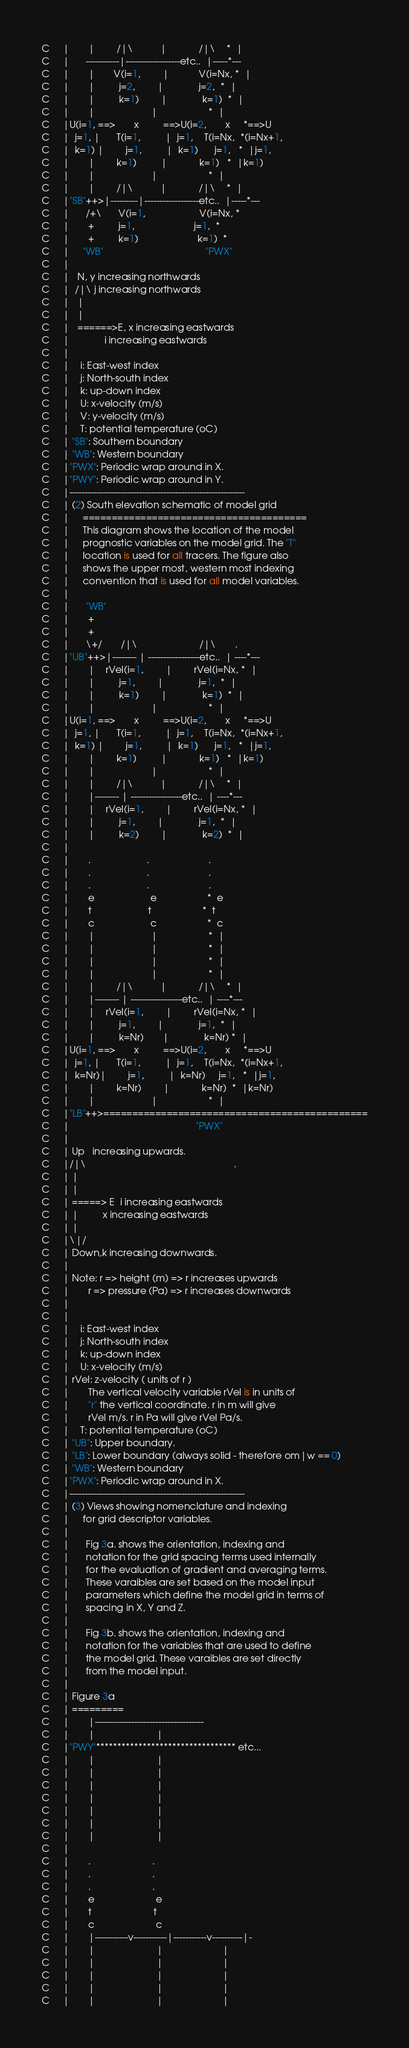Convert code to text. <code><loc_0><loc_0><loc_500><loc_500><_FORTRAN_>C     |       |        /|\          |            /|\    *  |
C     |      -----------|------------------etc..  |-----*---
C     |       |       V(i=1,        |           V(i=Nx, *  |
C     |       |         j=2,        |             j=2,  *  |
C     |       |         k=1)        |             k=1)  *  |
C     |       |                     |                   *  |
C     |U(i=1, ==>       x         ==>U(i=2,       x     *==>U
C     |  j=1, |      T(i=1,         |  j=1,    T(i=Nx,  *(i=Nx+1,
C     |  k=1) |        j=1,         |  k=1)      j=1,   *  |j=1,
C     |       |        k=1)         |            k=1)   *  |k=1)
C     |       |                     |                   *  |
C     |       |        /|\          |            /|\    *  |
C     |"SB"++>|---------|------------------etc..  |-----*---
C     |      /+\      V(i=1,                    V(i=Nx, *
C     |       +         j=1,                      j=1,  *
C     |       +         k=1)                      k=1)  *
C     |     "WB"                                      "PWX"
C     |
C     |   N, y increasing northwards
C     |  /|\ j increasing northwards
C     |   |
C     |   |
C     |   ======>E, x increasing eastwards
C     |             i increasing eastwards
C     |
C     |    i: East-west index
C     |    j: North-south index
C     |    k: up-down index
C     |    U: x-velocity (m/s)
C     |    V: y-velocity (m/s)
C     |    T: potential temperature (oC)
C     | "SB": Southern boundary
C     | "WB": Western boundary
C     |"PWX": Periodic wrap around in X.
C     |"PWY": Periodic wrap around in Y.
C     |----------------------------------------------------------
C     | (2) South elevation schematic of model grid
C     |     =======================================
C     |     This diagram shows the location of the model
C     |     prognostic variables on the model grid. The "T"
C     |     location is used for all tracers. The figure also
C     |     shows the upper most, western most indexing
C     |     convention that is used for all model variables.
C     |
C     |      "WB"
C     |       +
C     |       +
C     |      \+/       /|\                       /|\       .
C     |"UB"++>|-------- | -----------------etc..  | ----*---
C     |       |    rVel(i=1,        |        rVel(i=Nx, *  |
C     |       |         j=1,        |             j=1,  *  |
C     |       |         k=1)        |             k=1)  *  |
C     |       |                     |                   *  |
C     |U(i=1, ==>       x         ==>U(i=2,       x     *==>U
C     |  j=1, |      T(i=1,         |  j=1,    T(i=Nx,  *(i=Nx+1,
C     |  k=1) |        j=1,         |  k=1)      j=1,   *  |j=1,
C     |       |        k=1)         |            k=1)   *  |k=1)
C     |       |                     |                   *  |
C     |       |        /|\          |            /|\    *  |
C     |       |-------- | -----------------etc..  | ----*---
C     |       |    rVel(i=1,        |        rVel(i=Nx, *  |
C     |       |         j=1,        |             j=1,  *  |
C     |       |         k=2)        |             k=2)  *  |
C     |
C     |       .                     .                      .
C     |       .                     .                      .
C     |       .                     .                      .
C     |       e                     e                   *  e
C     |       t                     t                   *  t
C     |       c                     c                   *  c
C     |       |                     |                   *  |
C     |       |                     |                   *  |
C     |       |                     |                   *  |
C     |       |                     |                   *  |
C     |       |        /|\          |            /|\    *  |
C     |       |-------- | -----------------etc..  | ----*---
C     |       |    rVel(i=1,        |        rVel(i=Nx, *  |
C     |       |         j=1,        |             j=1,  *  |
C     |       |         k=Nr)       |             k=Nr) *  |
C     |U(i=1, ==>       x         ==>U(i=2,       x     *==>U
C     |  j=1, |      T(i=1,         |  j=1,    T(i=Nx,  *(i=Nx+1,
C     |  k=Nr)|        j=1,         |  k=Nr)     j=1,   *  |j=1,
C     |       |        k=Nr)        |            k=Nr)  *  |k=Nr)
C     |       |                     |                   *  |
C     |"LB"++>==============================================
C     |                                               "PWX"
C     |
C     | Up   increasing upwards.
C     |/|\                                                       .
C     | |
C     | |
C     | =====> E  i increasing eastwards
C     | |         x increasing eastwards
C     | |
C     |\|/
C     | Down,k increasing downwards.
C     |
C     | Note: r => height (m) => r increases upwards
C     |       r => pressure (Pa) => r increases downwards
C     |
C     |
C     |    i: East-west index
C     |    j: North-south index
C     |    k: up-down index
C     |    U: x-velocity (m/s)
C     | rVel: z-velocity ( units of r )
C     |       The vertical velocity variable rVel is in units of
C     |       "r" the vertical coordinate. r in m will give
C     |       rVel m/s. r in Pa will give rVel Pa/s.
C     |    T: potential temperature (oC)
C     | "UB": Upper boundary.
C     | "LB": Lower boundary (always solid - therefore om|w == 0)
C     | "WB": Western boundary
C     |"PWX": Periodic wrap around in X.
C     |----------------------------------------------------------
C     | (3) Views showing nomenclature and indexing
C     |     for grid descriptor variables.
C     |
C     |      Fig 3a. shows the orientation, indexing and
C     |      notation for the grid spacing terms used internally
C     |      for the evaluation of gradient and averaging terms.
C     |      These varaibles are set based on the model input
C     |      parameters which define the model grid in terms of
C     |      spacing in X, Y and Z.
C     |
C     |      Fig 3b. shows the orientation, indexing and
C     |      notation for the variables that are used to define
C     |      the model grid. These varaibles are set directly
C     |      from the model input.
C     |
C     | Figure 3a
C     | =========
C     |       |------------------------------------
C     |       |                       |
C     |"PWY"********************************* etc...
C     |       |                       |
C     |       |                       |
C     |       |                       |
C     |       |                       |
C     |       |                       |
C     |       |                       |
C     |       |                       |
C     |
C     |       .                       .
C     |       .                       .
C     |       .                       .
C     |       e                       e
C     |       t                       t
C     |       c                       c
C     |       |-----------v-----------|-----------v----------|-
C     |       |                       |                      |
C     |       |                       |                      |
C     |       |                       |                      |
C     |       |                       |                      |
C     |       |                       |                      |</code> 